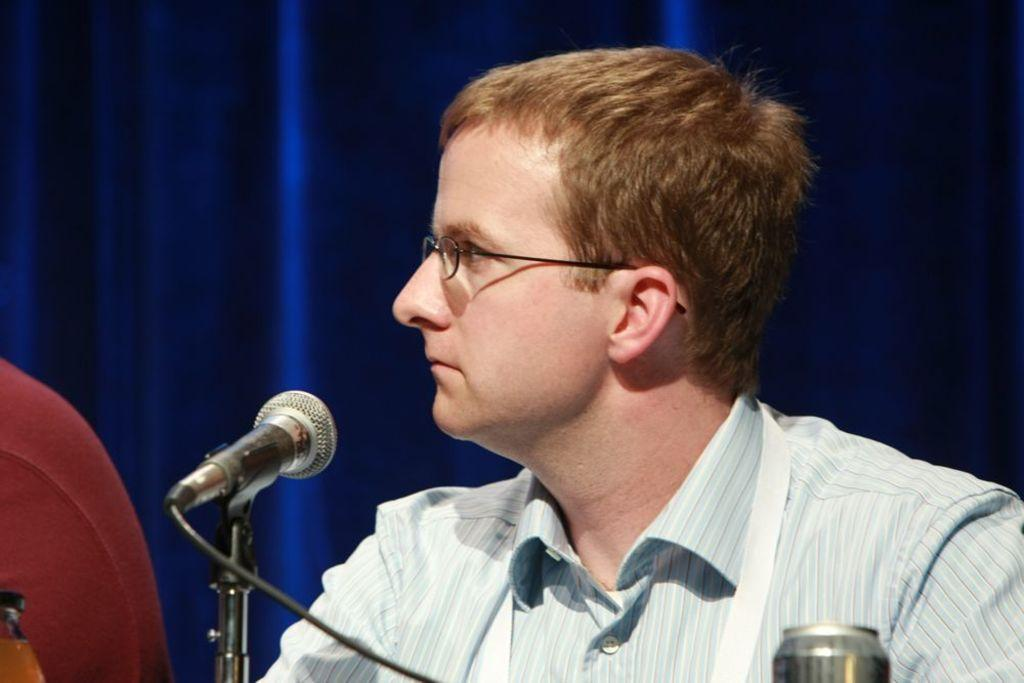What is the person in the image wearing? The person in the image is wearing spectacles. What can be seen connected to the microphone in the image? There is a wire connected to the microphone in the image. What is the person holding in the image? The person is holding a microphone in the image. What is the can in the image used for? The purpose of the can in the image is not specified, but it could be a beverage or container. What is the microphone stand used for? The microphone stand is used to hold and position the microphone for the person to use. Can you describe any other objects present in the image? There are other objects present in the image, but their specific details are not mentioned in the provided facts. Is there a cactus visible in the image? No, there is no cactus present in the image. Can you describe the bath that the person is taking in the image? There is no bath or any indication of bathing in the image. 